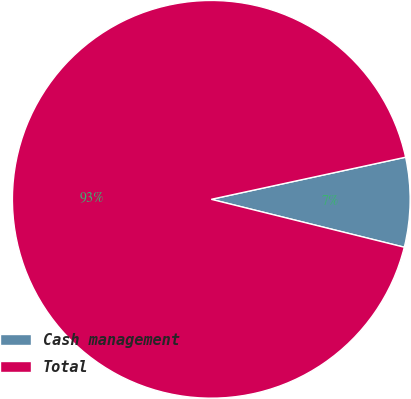Convert chart. <chart><loc_0><loc_0><loc_500><loc_500><pie_chart><fcel>Cash management<fcel>Total<nl><fcel>7.27%<fcel>92.73%<nl></chart> 